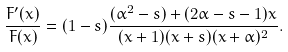Convert formula to latex. <formula><loc_0><loc_0><loc_500><loc_500>\frac { F ^ { \prime } ( x ) } { F ( x ) } = ( 1 - s ) \frac { ( \alpha ^ { 2 } - s ) + ( 2 \alpha - s - 1 ) x } { ( x + 1 ) ( x + s ) ( x + \alpha ) ^ { 2 } } .</formula> 